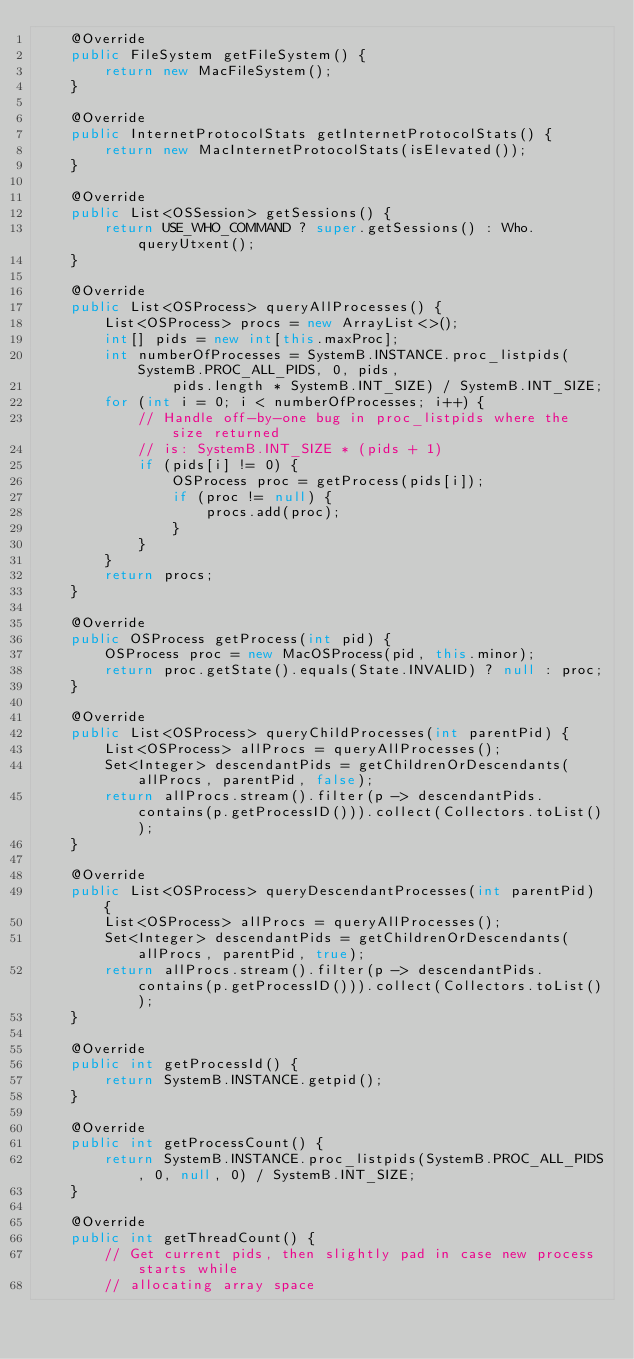<code> <loc_0><loc_0><loc_500><loc_500><_Java_>    @Override
    public FileSystem getFileSystem() {
        return new MacFileSystem();
    }

    @Override
    public InternetProtocolStats getInternetProtocolStats() {
        return new MacInternetProtocolStats(isElevated());
    }

    @Override
    public List<OSSession> getSessions() {
        return USE_WHO_COMMAND ? super.getSessions() : Who.queryUtxent();
    }

    @Override
    public List<OSProcess> queryAllProcesses() {
        List<OSProcess> procs = new ArrayList<>();
        int[] pids = new int[this.maxProc];
        int numberOfProcesses = SystemB.INSTANCE.proc_listpids(SystemB.PROC_ALL_PIDS, 0, pids,
                pids.length * SystemB.INT_SIZE) / SystemB.INT_SIZE;
        for (int i = 0; i < numberOfProcesses; i++) {
            // Handle off-by-one bug in proc_listpids where the size returned
            // is: SystemB.INT_SIZE * (pids + 1)
            if (pids[i] != 0) {
                OSProcess proc = getProcess(pids[i]);
                if (proc != null) {
                    procs.add(proc);
                }
            }
        }
        return procs;
    }

    @Override
    public OSProcess getProcess(int pid) {
        OSProcess proc = new MacOSProcess(pid, this.minor);
        return proc.getState().equals(State.INVALID) ? null : proc;
    }

    @Override
    public List<OSProcess> queryChildProcesses(int parentPid) {
        List<OSProcess> allProcs = queryAllProcesses();
        Set<Integer> descendantPids = getChildrenOrDescendants(allProcs, parentPid, false);
        return allProcs.stream().filter(p -> descendantPids.contains(p.getProcessID())).collect(Collectors.toList());
    }

    @Override
    public List<OSProcess> queryDescendantProcesses(int parentPid) {
        List<OSProcess> allProcs = queryAllProcesses();
        Set<Integer> descendantPids = getChildrenOrDescendants(allProcs, parentPid, true);
        return allProcs.stream().filter(p -> descendantPids.contains(p.getProcessID())).collect(Collectors.toList());
    }

    @Override
    public int getProcessId() {
        return SystemB.INSTANCE.getpid();
    }

    @Override
    public int getProcessCount() {
        return SystemB.INSTANCE.proc_listpids(SystemB.PROC_ALL_PIDS, 0, null, 0) / SystemB.INT_SIZE;
    }

    @Override
    public int getThreadCount() {
        // Get current pids, then slightly pad in case new process starts while
        // allocating array space</code> 